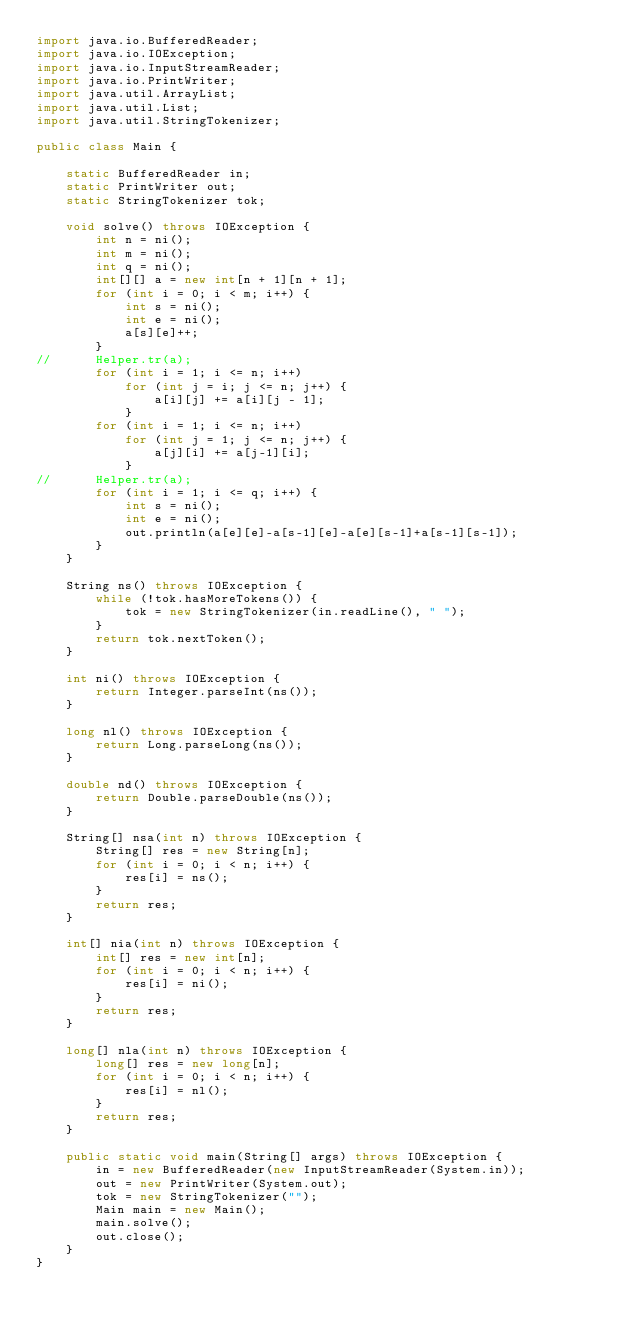Convert code to text. <code><loc_0><loc_0><loc_500><loc_500><_Java_>import java.io.BufferedReader;
import java.io.IOException;
import java.io.InputStreamReader;
import java.io.PrintWriter;
import java.util.ArrayList;
import java.util.List;
import java.util.StringTokenizer;

public class Main {

	static BufferedReader in;
	static PrintWriter out;
	static StringTokenizer tok;

	void solve() throws IOException {
		int n = ni();
		int m = ni();
		int q = ni();
		int[][] a = new int[n + 1][n + 1];
		for (int i = 0; i < m; i++) {
			int s = ni();
			int e = ni();
			a[s][e]++;
		}
//		Helper.tr(a);
		for (int i = 1; i <= n; i++)
			for (int j = i; j <= n; j++) {
				a[i][j] += a[i][j - 1];
			}
		for (int i = 1; i <= n; i++)
			for (int j = 1; j <= n; j++) {
				a[j][i] += a[j-1][i];
			}
//		Helper.tr(a);
		for (int i = 1; i <= q; i++) {
			int s = ni();
			int e = ni();
			out.println(a[e][e]-a[s-1][e]-a[e][s-1]+a[s-1][s-1]);
		}
	}

	String ns() throws IOException {
		while (!tok.hasMoreTokens()) {
			tok = new StringTokenizer(in.readLine(), " ");
		}
		return tok.nextToken();
	}

	int ni() throws IOException {
		return Integer.parseInt(ns());
	}

	long nl() throws IOException {
		return Long.parseLong(ns());
	}

	double nd() throws IOException {
		return Double.parseDouble(ns());
	}

	String[] nsa(int n) throws IOException {
		String[] res = new String[n];
		for (int i = 0; i < n; i++) {
			res[i] = ns();
		}
		return res;
	}

	int[] nia(int n) throws IOException {
		int[] res = new int[n];
		for (int i = 0; i < n; i++) {
			res[i] = ni();
		}
		return res;
	}

	long[] nla(int n) throws IOException {
		long[] res = new long[n];
		for (int i = 0; i < n; i++) {
			res[i] = nl();
		}
		return res;
	}

	public static void main(String[] args) throws IOException {
		in = new BufferedReader(new InputStreamReader(System.in));
		out = new PrintWriter(System.out);
		tok = new StringTokenizer("");
		Main main = new Main();
		main.solve();
		out.close();
	}
}</code> 